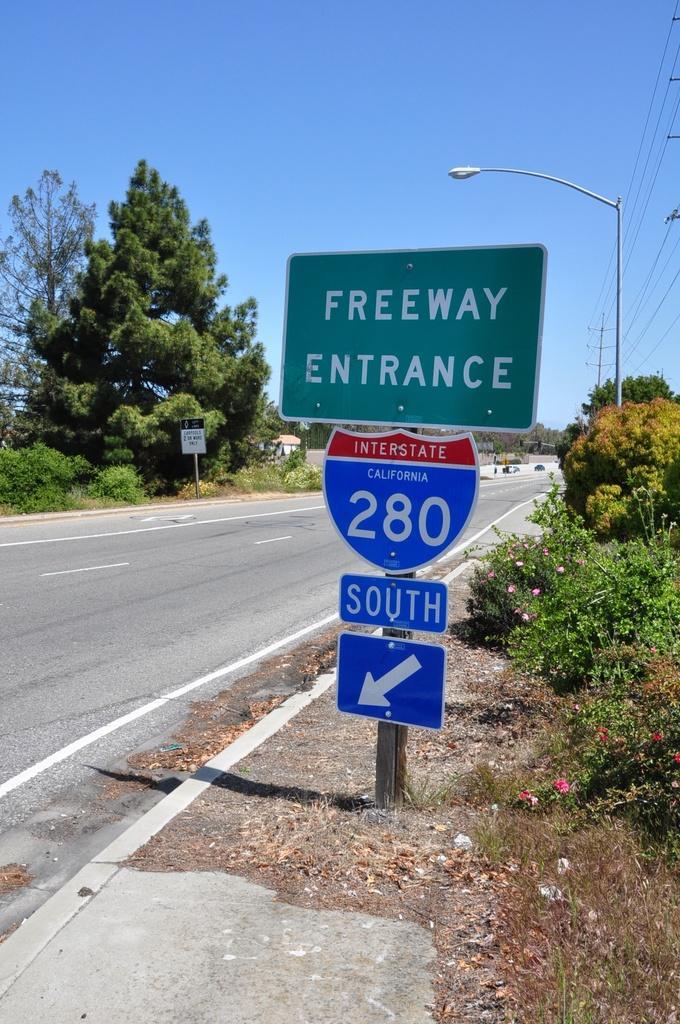In one or two sentences, can you explain what this image depicts? In the background we can see the sky, house. On either side of the road we can see the trees, plants, poles. In this picture we can see the transmission wires, light pole, flowers. We can see the boards with some information. 